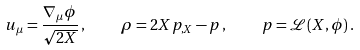<formula> <loc_0><loc_0><loc_500><loc_500>u _ { \mu } = \frac { \nabla _ { \mu } \phi } { \sqrt { 2 X } } \, , \quad \rho = 2 X p _ { , X } - p \, , \quad p = { \mathcal { L } } ( X , \phi ) \, .</formula> 